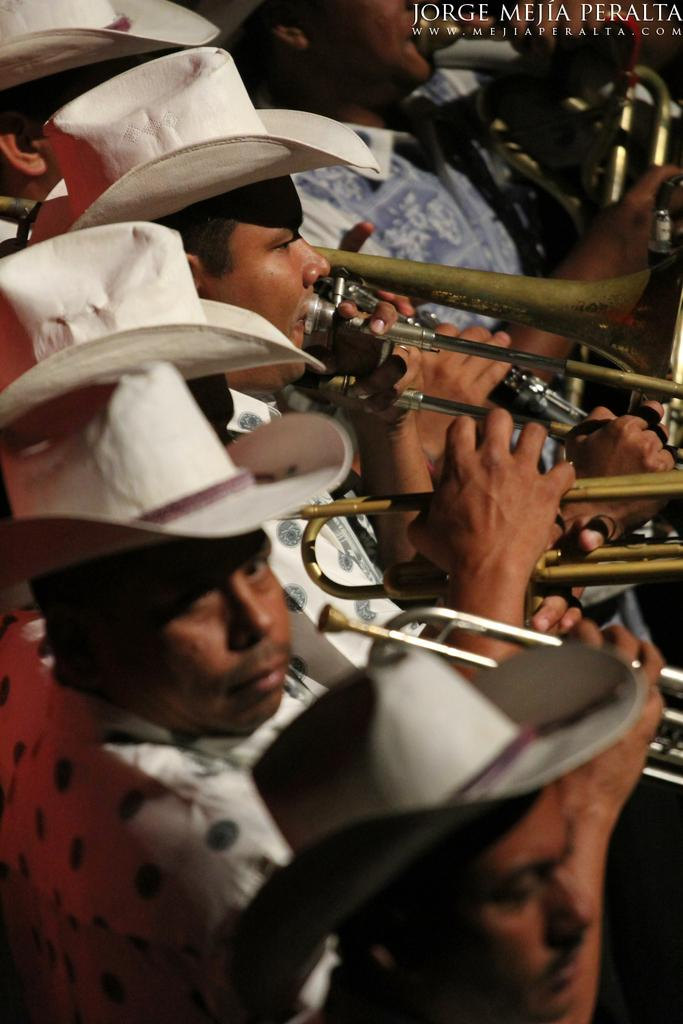Who or what is present in the image? There are people in the image. What are the people wearing on their heads? The people are wearing white hats. What are the people doing in the image? The people are playing trombones. What can be seen at the top of the image? There is text visible at the top of the image. What year is depicted in the image? There is no specific year depicted in the image; it only shows people playing trombones and wearing white hats. Can you describe the attack that is happening in the image? There is no attack depicted in the image; it only shows people playing trombones and wearing white hats. 